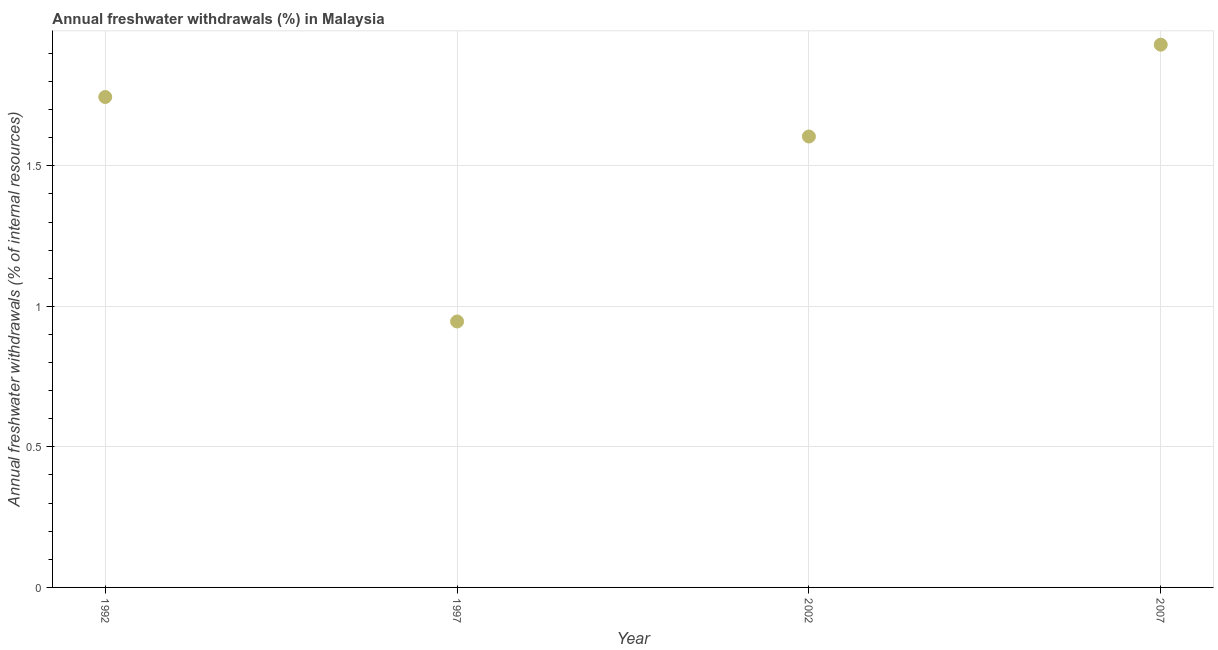What is the annual freshwater withdrawals in 2002?
Give a very brief answer. 1.6. Across all years, what is the maximum annual freshwater withdrawals?
Provide a succinct answer. 1.93. Across all years, what is the minimum annual freshwater withdrawals?
Your answer should be compact. 0.95. What is the sum of the annual freshwater withdrawals?
Your answer should be compact. 6.23. What is the difference between the annual freshwater withdrawals in 1992 and 2002?
Your response must be concise. 0.14. What is the average annual freshwater withdrawals per year?
Give a very brief answer. 1.56. What is the median annual freshwater withdrawals?
Provide a succinct answer. 1.67. Do a majority of the years between 2002 and 2007 (inclusive) have annual freshwater withdrawals greater than 1.2 %?
Your answer should be compact. Yes. What is the ratio of the annual freshwater withdrawals in 1997 to that in 2007?
Your answer should be compact. 0.49. Is the annual freshwater withdrawals in 1997 less than that in 2007?
Your response must be concise. Yes. What is the difference between the highest and the second highest annual freshwater withdrawals?
Give a very brief answer. 0.19. Is the sum of the annual freshwater withdrawals in 1997 and 2002 greater than the maximum annual freshwater withdrawals across all years?
Provide a short and direct response. Yes. What is the difference between the highest and the lowest annual freshwater withdrawals?
Your response must be concise. 0.98. Does the annual freshwater withdrawals monotonically increase over the years?
Offer a very short reply. No. Does the graph contain any zero values?
Provide a succinct answer. No. What is the title of the graph?
Your answer should be very brief. Annual freshwater withdrawals (%) in Malaysia. What is the label or title of the X-axis?
Give a very brief answer. Year. What is the label or title of the Y-axis?
Offer a terse response. Annual freshwater withdrawals (% of internal resources). What is the Annual freshwater withdrawals (% of internal resources) in 1992?
Offer a very short reply. 1.74. What is the Annual freshwater withdrawals (% of internal resources) in 1997?
Your response must be concise. 0.95. What is the Annual freshwater withdrawals (% of internal resources) in 2002?
Give a very brief answer. 1.6. What is the Annual freshwater withdrawals (% of internal resources) in 2007?
Provide a short and direct response. 1.93. What is the difference between the Annual freshwater withdrawals (% of internal resources) in 1992 and 1997?
Your response must be concise. 0.8. What is the difference between the Annual freshwater withdrawals (% of internal resources) in 1992 and 2002?
Your answer should be compact. 0.14. What is the difference between the Annual freshwater withdrawals (% of internal resources) in 1992 and 2007?
Give a very brief answer. -0.19. What is the difference between the Annual freshwater withdrawals (% of internal resources) in 1997 and 2002?
Provide a succinct answer. -0.66. What is the difference between the Annual freshwater withdrawals (% of internal resources) in 1997 and 2007?
Ensure brevity in your answer.  -0.98. What is the difference between the Annual freshwater withdrawals (% of internal resources) in 2002 and 2007?
Offer a very short reply. -0.33. What is the ratio of the Annual freshwater withdrawals (% of internal resources) in 1992 to that in 1997?
Ensure brevity in your answer.  1.84. What is the ratio of the Annual freshwater withdrawals (% of internal resources) in 1992 to that in 2002?
Your response must be concise. 1.09. What is the ratio of the Annual freshwater withdrawals (% of internal resources) in 1992 to that in 2007?
Give a very brief answer. 0.9. What is the ratio of the Annual freshwater withdrawals (% of internal resources) in 1997 to that in 2002?
Provide a succinct answer. 0.59. What is the ratio of the Annual freshwater withdrawals (% of internal resources) in 1997 to that in 2007?
Your response must be concise. 0.49. What is the ratio of the Annual freshwater withdrawals (% of internal resources) in 2002 to that in 2007?
Make the answer very short. 0.83. 